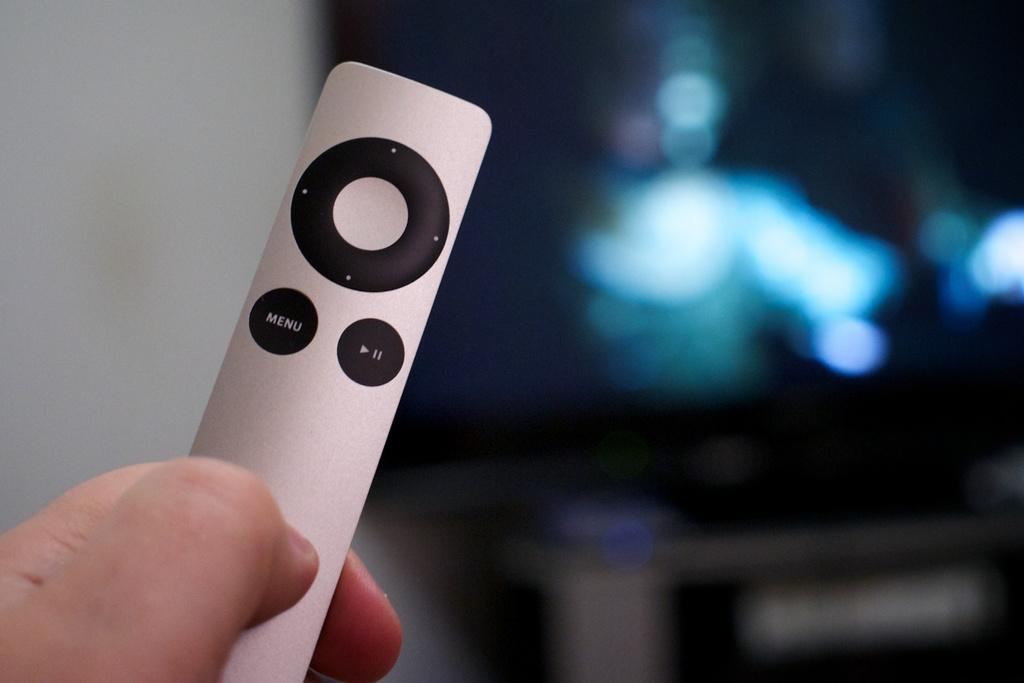<image>
Render a clear and concise summary of the photo. A small silver remote features a Menu button. 